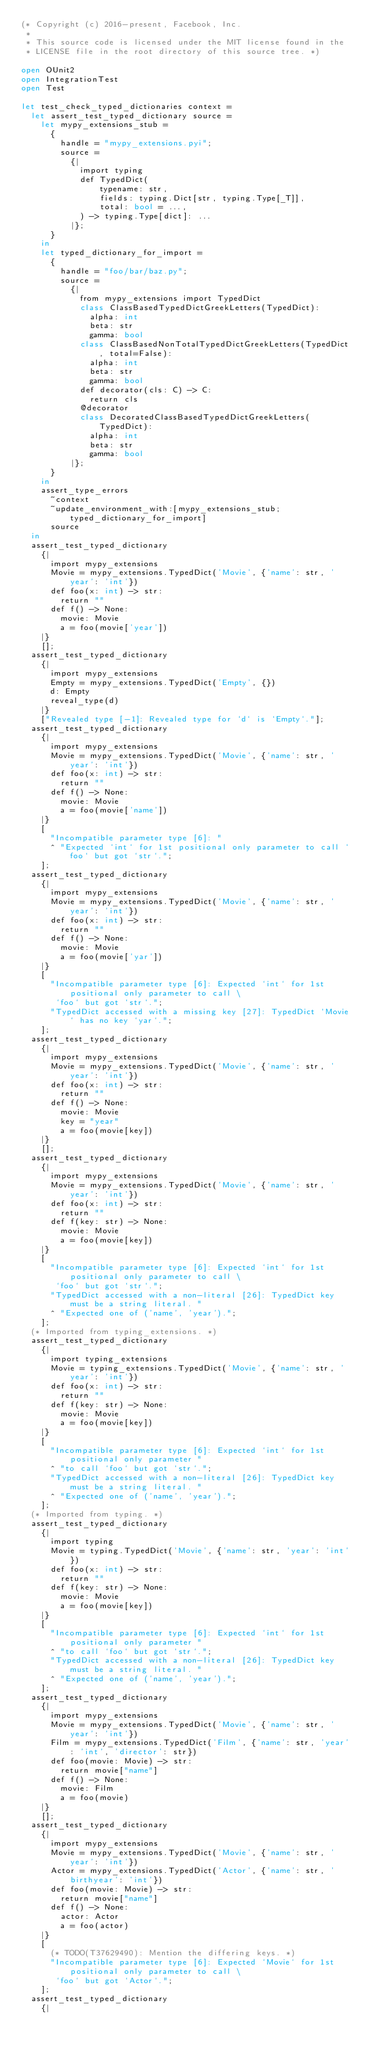<code> <loc_0><loc_0><loc_500><loc_500><_OCaml_>(* Copyright (c) 2016-present, Facebook, Inc.
 *
 * This source code is licensed under the MIT license found in the
 * LICENSE file in the root directory of this source tree. *)

open OUnit2
open IntegrationTest
open Test

let test_check_typed_dictionaries context =
  let assert_test_typed_dictionary source =
    let mypy_extensions_stub =
      {
        handle = "mypy_extensions.pyi";
        source =
          {|
            import typing
            def TypedDict(
                typename: str,
                fields: typing.Dict[str, typing.Type[_T]],
                total: bool = ...,
            ) -> typing.Type[dict]: ...
          |};
      }
    in
    let typed_dictionary_for_import =
      {
        handle = "foo/bar/baz.py";
        source =
          {|
            from mypy_extensions import TypedDict
            class ClassBasedTypedDictGreekLetters(TypedDict):
              alpha: int
              beta: str
              gamma: bool
            class ClassBasedNonTotalTypedDictGreekLetters(TypedDict, total=False):
              alpha: int
              beta: str
              gamma: bool
            def decorator(cls: C) -> C:
              return cls
            @decorator
            class DecoratedClassBasedTypedDictGreekLetters(TypedDict):
              alpha: int
              beta: str
              gamma: bool
          |};
      }
    in
    assert_type_errors
      ~context
      ~update_environment_with:[mypy_extensions_stub; typed_dictionary_for_import]
      source
  in
  assert_test_typed_dictionary
    {|
      import mypy_extensions
      Movie = mypy_extensions.TypedDict('Movie', {'name': str, 'year': 'int'})
      def foo(x: int) -> str:
        return ""
      def f() -> None:
        movie: Movie
        a = foo(movie['year'])
    |}
    [];
  assert_test_typed_dictionary
    {|
      import mypy_extensions
      Empty = mypy_extensions.TypedDict('Empty', {})
      d: Empty
      reveal_type(d)
    |}
    ["Revealed type [-1]: Revealed type for `d` is `Empty`."];
  assert_test_typed_dictionary
    {|
      import mypy_extensions
      Movie = mypy_extensions.TypedDict('Movie', {'name': str, 'year': 'int'})
      def foo(x: int) -> str:
        return ""
      def f() -> None:
        movie: Movie
        a = foo(movie['name'])
    |}
    [
      "Incompatible parameter type [6]: "
      ^ "Expected `int` for 1st positional only parameter to call `foo` but got `str`.";
    ];
  assert_test_typed_dictionary
    {|
      import mypy_extensions
      Movie = mypy_extensions.TypedDict('Movie', {'name': str, 'year': 'int'})
      def foo(x: int) -> str:
        return ""
      def f() -> None:
        movie: Movie
        a = foo(movie['yar'])
    |}
    [
      "Incompatible parameter type [6]: Expected `int` for 1st positional only parameter to call \
       `foo` but got `str`.";
      "TypedDict accessed with a missing key [27]: TypedDict `Movie` has no key `yar`.";
    ];
  assert_test_typed_dictionary
    {|
      import mypy_extensions
      Movie = mypy_extensions.TypedDict('Movie', {'name': str, 'year': 'int'})
      def foo(x: int) -> str:
        return ""
      def f() -> None:
        movie: Movie
        key = "year"
        a = foo(movie[key])
    |}
    [];
  assert_test_typed_dictionary
    {|
      import mypy_extensions
      Movie = mypy_extensions.TypedDict('Movie', {'name': str, 'year': 'int'})
      def foo(x: int) -> str:
        return ""
      def f(key: str) -> None:
        movie: Movie
        a = foo(movie[key])
    |}
    [
      "Incompatible parameter type [6]: Expected `int` for 1st positional only parameter to call \
       `foo` but got `str`.";
      "TypedDict accessed with a non-literal [26]: TypedDict key must be a string literal. "
      ^ "Expected one of ('name', 'year').";
    ];
  (* Imported from typing_extensions. *)
  assert_test_typed_dictionary
    {|
      import typing_extensions
      Movie = typing_extensions.TypedDict('Movie', {'name': str, 'year': 'int'})
      def foo(x: int) -> str:
        return ""
      def f(key: str) -> None:
        movie: Movie
        a = foo(movie[key])
    |}
    [
      "Incompatible parameter type [6]: Expected `int` for 1st positional only parameter "
      ^ "to call `foo` but got `str`.";
      "TypedDict accessed with a non-literal [26]: TypedDict key must be a string literal. "
      ^ "Expected one of ('name', 'year').";
    ];
  (* Imported from typing. *)
  assert_test_typed_dictionary
    {|
      import typing
      Movie = typing.TypedDict('Movie', {'name': str, 'year': 'int'})
      def foo(x: int) -> str:
        return ""
      def f(key: str) -> None:
        movie: Movie
        a = foo(movie[key])
    |}
    [
      "Incompatible parameter type [6]: Expected `int` for 1st positional only parameter "
      ^ "to call `foo` but got `str`.";
      "TypedDict accessed with a non-literal [26]: TypedDict key must be a string literal. "
      ^ "Expected one of ('name', 'year').";
    ];
  assert_test_typed_dictionary
    {|
      import mypy_extensions
      Movie = mypy_extensions.TypedDict('Movie', {'name': str, 'year': 'int'})
      Film = mypy_extensions.TypedDict('Film', {'name': str, 'year': 'int', 'director': str})
      def foo(movie: Movie) -> str:
        return movie["name"]
      def f() -> None:
        movie: Film
        a = foo(movie)
    |}
    [];
  assert_test_typed_dictionary
    {|
      import mypy_extensions
      Movie = mypy_extensions.TypedDict('Movie', {'name': str, 'year': 'int'})
      Actor = mypy_extensions.TypedDict('Actor', {'name': str, 'birthyear': 'int'})
      def foo(movie: Movie) -> str:
        return movie["name"]
      def f() -> None:
        actor: Actor
        a = foo(actor)
    |}
    [
      (* TODO(T37629490): Mention the differing keys. *)
      "Incompatible parameter type [6]: Expected `Movie` for 1st positional only parameter to call \
       `foo` but got `Actor`.";
    ];
  assert_test_typed_dictionary
    {|</code> 